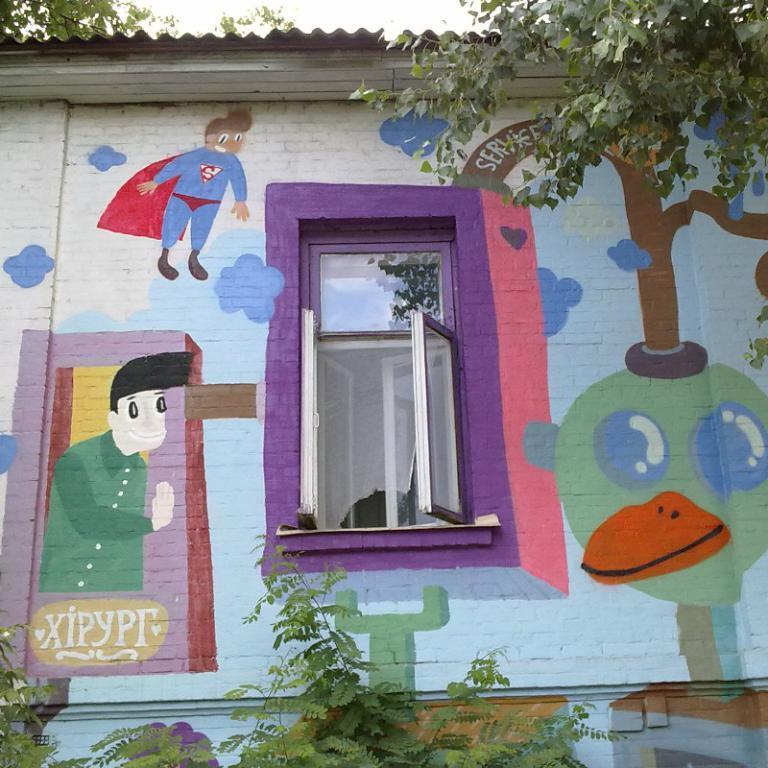Describe this image in one or two sentences. In this image there is a wall with cartoon paintings on it. At the center of the wall there is a glass window and there are trees at the bottom of the image. 